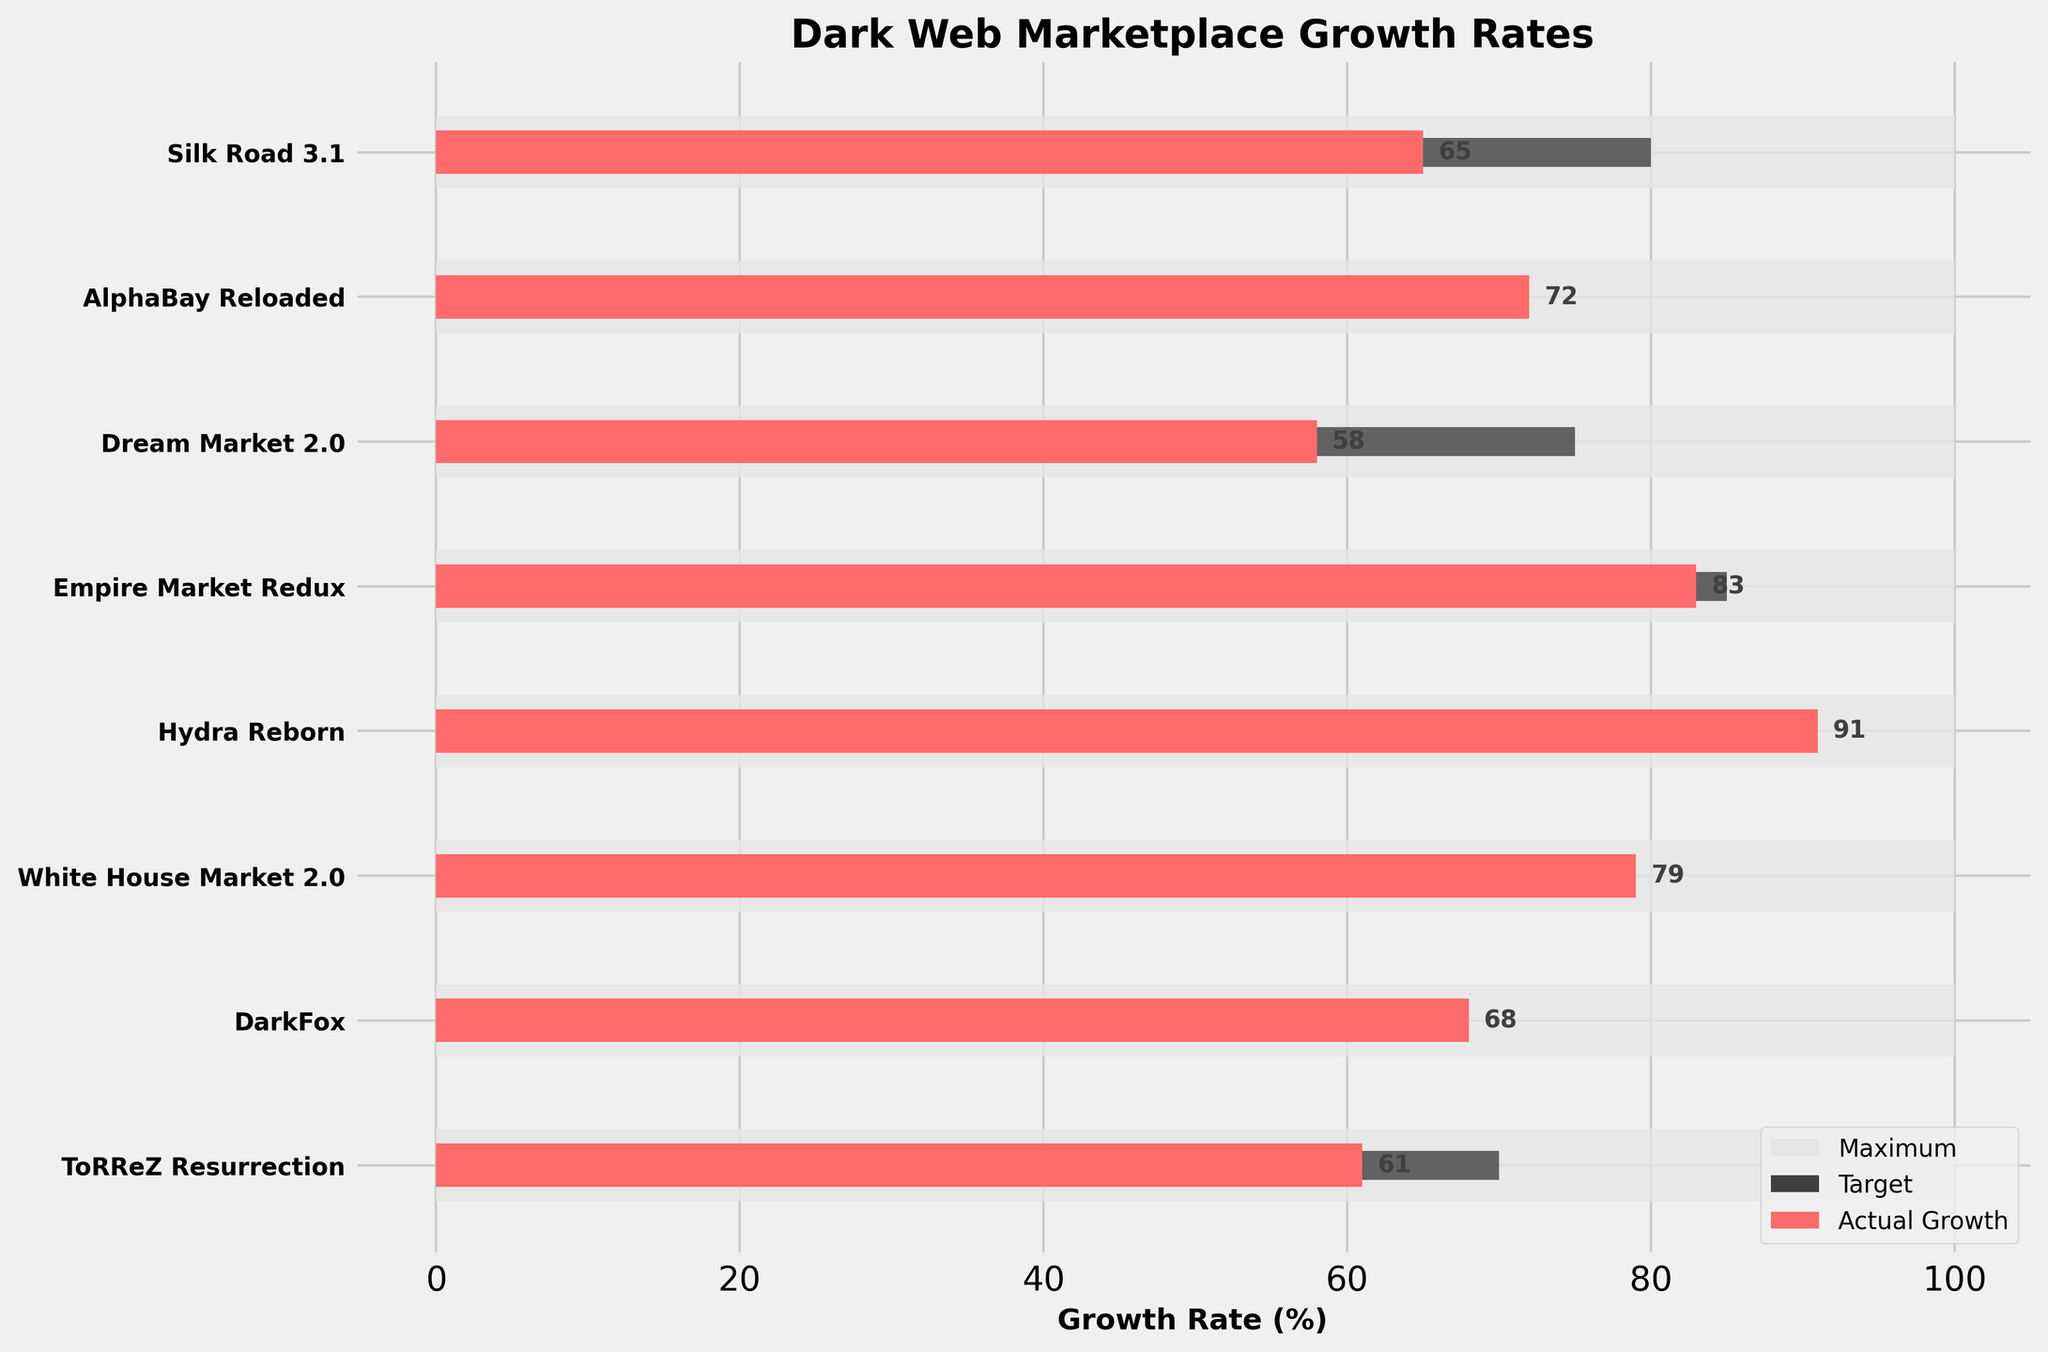What is the title of the bullet chart? The title is displayed at the top of the chart. It reads "Dark Web Marketplace Growth Rates."
Answer: Dark Web Marketplace Growth Rates What color represents the actual growth bars? In the chart, the actual growth bars are colored in red, which is easily distinguishable from the other colors used for the target and maximum values.
Answer: Red What is the target growth rate for the Hydra Reborn marketplace? The target growth rate can be found by looking at the horizontal bar that is colored dark grey corresponding to Hydra Reborn. The value is located at the end of the dark grey bar.
Answer: 80% Which marketplace has the highest actual growth rate? To find this, look for the longest red bar in the chart. Hydra Reborn has the longest red bar among all the marketplaces.
Answer: Hydra Reborn How does the actual growth rate of Empire Market Redux compare to its target growth rate? Check the red bar (actual growth) and the dark grey bar (target growth) for Empire Market Redux. The actual growth is 83%, and the target is 85%.
Answer: It is 2% below the target How much higher is the actual growth rate of AlphaBay Reloaded than that of ToRReZ Resurrection? First, identify the actual growth rates for both marketplaces from their red bars. AlphaBay Reloaded is at 72% and ToRReZ Resurrection is at 61%. The difference is 72% - 61% = 11%.
Answer: 11% Which marketplace met or exceeded its target growth rate? Compare the red bars (actual growth) to the dark grey bars (target) for each marketplace. AlphaBay Reloaded and Hydra Reborn are the marketplaces where the actual growth is greater than or equal to the target.
Answer: AlphaBay Reloaded, Hydra Reborn What is the average target growth rate across all marketplaces? Add all the target values (80 + 70 + 75 + 85 + 80 + 75 + 65 + 70) and divide by the number of marketplaces (8). The sum is 600, and the number of marketplaces is 8, so the average is 600/8.
Answer: 75% How many marketplaces have an actual growth rate above 70%? Identify the actual growth rates from the red bars and count those above 70%. The marketplaces are AlphaBay Reloaded, Empire Market Redux, Hydra Reborn, and White House Market 2.0. There are 4 such marketplaces.
Answer: 4 